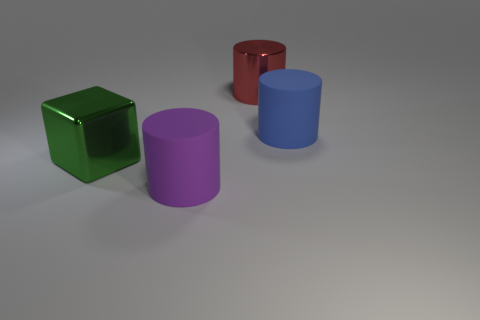Add 1 big green blocks. How many objects exist? 5 Subtract all cylinders. How many objects are left? 1 Subtract 0 purple balls. How many objects are left? 4 Subtract all big green metallic spheres. Subtract all red cylinders. How many objects are left? 3 Add 2 matte cylinders. How many matte cylinders are left? 4 Add 1 big cylinders. How many big cylinders exist? 4 